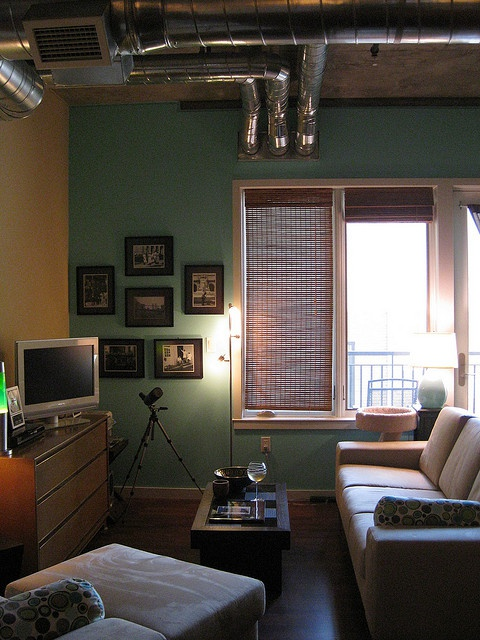Describe the objects in this image and their specific colors. I can see couch in black, gray, and lavender tones, couch in black and gray tones, tv in black and gray tones, bowl in black, gray, and white tones, and wine glass in black, gray, darkgreen, and darkgray tones in this image. 